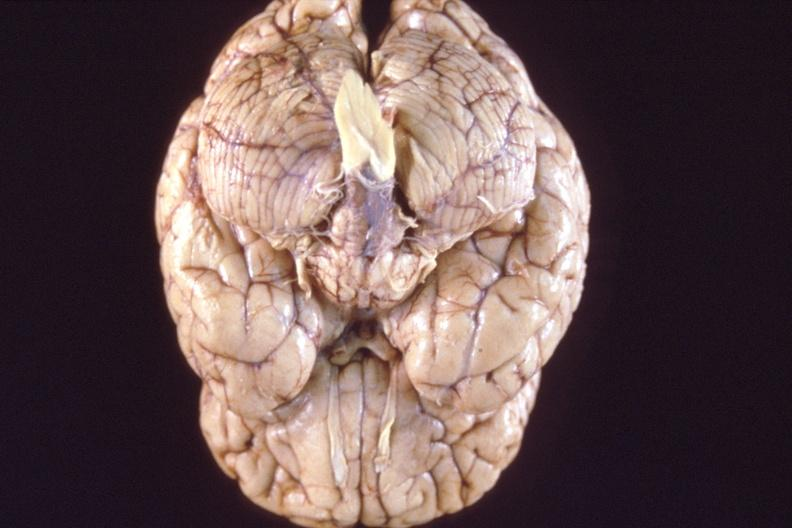s soft tissue present?
Answer the question using a single word or phrase. No 